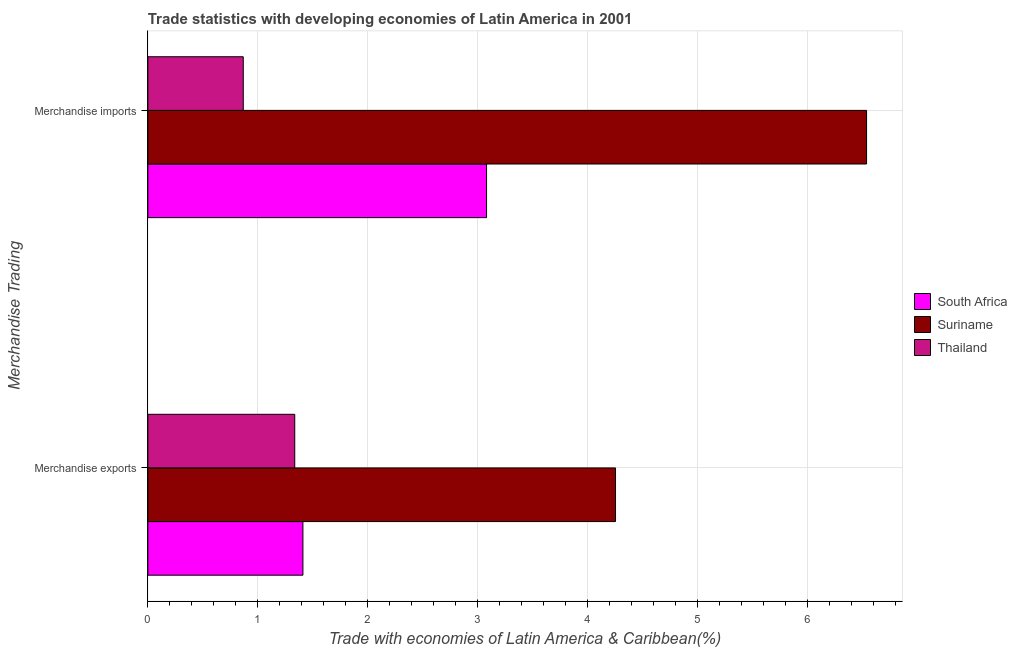How many groups of bars are there?
Make the answer very short. 2. Are the number of bars per tick equal to the number of legend labels?
Provide a succinct answer. Yes. Are the number of bars on each tick of the Y-axis equal?
Make the answer very short. Yes. How many bars are there on the 1st tick from the top?
Provide a short and direct response. 3. How many bars are there on the 1st tick from the bottom?
Offer a very short reply. 3. What is the merchandise exports in Thailand?
Provide a succinct answer. 1.34. Across all countries, what is the maximum merchandise exports?
Offer a terse response. 4.25. Across all countries, what is the minimum merchandise exports?
Ensure brevity in your answer.  1.34. In which country was the merchandise exports maximum?
Your response must be concise. Suriname. In which country was the merchandise exports minimum?
Provide a short and direct response. Thailand. What is the total merchandise imports in the graph?
Provide a short and direct response. 10.48. What is the difference between the merchandise exports in Thailand and that in South Africa?
Your answer should be compact. -0.07. What is the difference between the merchandise exports in Suriname and the merchandise imports in Thailand?
Provide a short and direct response. 3.38. What is the average merchandise exports per country?
Provide a succinct answer. 2.33. What is the difference between the merchandise exports and merchandise imports in South Africa?
Keep it short and to the point. -1.67. In how many countries, is the merchandise exports greater than 2 %?
Give a very brief answer. 1. What is the ratio of the merchandise imports in Suriname to that in South Africa?
Offer a very short reply. 2.12. Is the merchandise imports in Suriname less than that in Thailand?
Offer a very short reply. No. What does the 2nd bar from the top in Merchandise exports represents?
Provide a short and direct response. Suriname. What does the 2nd bar from the bottom in Merchandise imports represents?
Make the answer very short. Suriname. How many countries are there in the graph?
Your response must be concise. 3. Where does the legend appear in the graph?
Provide a short and direct response. Center right. How many legend labels are there?
Give a very brief answer. 3. What is the title of the graph?
Offer a very short reply. Trade statistics with developing economies of Latin America in 2001. What is the label or title of the X-axis?
Give a very brief answer. Trade with economies of Latin America & Caribbean(%). What is the label or title of the Y-axis?
Ensure brevity in your answer.  Merchandise Trading. What is the Trade with economies of Latin America & Caribbean(%) of South Africa in Merchandise exports?
Give a very brief answer. 1.41. What is the Trade with economies of Latin America & Caribbean(%) of Suriname in Merchandise exports?
Provide a short and direct response. 4.25. What is the Trade with economies of Latin America & Caribbean(%) of Thailand in Merchandise exports?
Your answer should be compact. 1.34. What is the Trade with economies of Latin America & Caribbean(%) of South Africa in Merchandise imports?
Make the answer very short. 3.08. What is the Trade with economies of Latin America & Caribbean(%) of Suriname in Merchandise imports?
Offer a very short reply. 6.53. What is the Trade with economies of Latin America & Caribbean(%) of Thailand in Merchandise imports?
Ensure brevity in your answer.  0.87. Across all Merchandise Trading, what is the maximum Trade with economies of Latin America & Caribbean(%) of South Africa?
Offer a very short reply. 3.08. Across all Merchandise Trading, what is the maximum Trade with economies of Latin America & Caribbean(%) in Suriname?
Your answer should be compact. 6.53. Across all Merchandise Trading, what is the maximum Trade with economies of Latin America & Caribbean(%) of Thailand?
Your response must be concise. 1.34. Across all Merchandise Trading, what is the minimum Trade with economies of Latin America & Caribbean(%) of South Africa?
Your response must be concise. 1.41. Across all Merchandise Trading, what is the minimum Trade with economies of Latin America & Caribbean(%) in Suriname?
Your response must be concise. 4.25. Across all Merchandise Trading, what is the minimum Trade with economies of Latin America & Caribbean(%) of Thailand?
Provide a succinct answer. 0.87. What is the total Trade with economies of Latin America & Caribbean(%) of South Africa in the graph?
Provide a short and direct response. 4.49. What is the total Trade with economies of Latin America & Caribbean(%) of Suriname in the graph?
Your response must be concise. 10.78. What is the total Trade with economies of Latin America & Caribbean(%) of Thailand in the graph?
Offer a very short reply. 2.2. What is the difference between the Trade with economies of Latin America & Caribbean(%) of South Africa in Merchandise exports and that in Merchandise imports?
Provide a succinct answer. -1.67. What is the difference between the Trade with economies of Latin America & Caribbean(%) in Suriname in Merchandise exports and that in Merchandise imports?
Ensure brevity in your answer.  -2.28. What is the difference between the Trade with economies of Latin America & Caribbean(%) in Thailand in Merchandise exports and that in Merchandise imports?
Give a very brief answer. 0.47. What is the difference between the Trade with economies of Latin America & Caribbean(%) in South Africa in Merchandise exports and the Trade with economies of Latin America & Caribbean(%) in Suriname in Merchandise imports?
Give a very brief answer. -5.12. What is the difference between the Trade with economies of Latin America & Caribbean(%) in South Africa in Merchandise exports and the Trade with economies of Latin America & Caribbean(%) in Thailand in Merchandise imports?
Provide a succinct answer. 0.54. What is the difference between the Trade with economies of Latin America & Caribbean(%) of Suriname in Merchandise exports and the Trade with economies of Latin America & Caribbean(%) of Thailand in Merchandise imports?
Your answer should be compact. 3.38. What is the average Trade with economies of Latin America & Caribbean(%) in South Africa per Merchandise Trading?
Your answer should be very brief. 2.24. What is the average Trade with economies of Latin America & Caribbean(%) in Suriname per Merchandise Trading?
Offer a very short reply. 5.39. What is the average Trade with economies of Latin America & Caribbean(%) in Thailand per Merchandise Trading?
Give a very brief answer. 1.1. What is the difference between the Trade with economies of Latin America & Caribbean(%) in South Africa and Trade with economies of Latin America & Caribbean(%) in Suriname in Merchandise exports?
Your answer should be compact. -2.84. What is the difference between the Trade with economies of Latin America & Caribbean(%) of South Africa and Trade with economies of Latin America & Caribbean(%) of Thailand in Merchandise exports?
Offer a terse response. 0.07. What is the difference between the Trade with economies of Latin America & Caribbean(%) in Suriname and Trade with economies of Latin America & Caribbean(%) in Thailand in Merchandise exports?
Make the answer very short. 2.92. What is the difference between the Trade with economies of Latin America & Caribbean(%) in South Africa and Trade with economies of Latin America & Caribbean(%) in Suriname in Merchandise imports?
Provide a short and direct response. -3.45. What is the difference between the Trade with economies of Latin America & Caribbean(%) of South Africa and Trade with economies of Latin America & Caribbean(%) of Thailand in Merchandise imports?
Keep it short and to the point. 2.21. What is the difference between the Trade with economies of Latin America & Caribbean(%) in Suriname and Trade with economies of Latin America & Caribbean(%) in Thailand in Merchandise imports?
Provide a succinct answer. 5.67. What is the ratio of the Trade with economies of Latin America & Caribbean(%) of South Africa in Merchandise exports to that in Merchandise imports?
Provide a short and direct response. 0.46. What is the ratio of the Trade with economies of Latin America & Caribbean(%) of Suriname in Merchandise exports to that in Merchandise imports?
Keep it short and to the point. 0.65. What is the ratio of the Trade with economies of Latin America & Caribbean(%) of Thailand in Merchandise exports to that in Merchandise imports?
Provide a short and direct response. 1.54. What is the difference between the highest and the second highest Trade with economies of Latin America & Caribbean(%) in South Africa?
Offer a very short reply. 1.67. What is the difference between the highest and the second highest Trade with economies of Latin America & Caribbean(%) in Suriname?
Make the answer very short. 2.28. What is the difference between the highest and the second highest Trade with economies of Latin America & Caribbean(%) in Thailand?
Offer a very short reply. 0.47. What is the difference between the highest and the lowest Trade with economies of Latin America & Caribbean(%) of South Africa?
Offer a terse response. 1.67. What is the difference between the highest and the lowest Trade with economies of Latin America & Caribbean(%) in Suriname?
Provide a succinct answer. 2.28. What is the difference between the highest and the lowest Trade with economies of Latin America & Caribbean(%) of Thailand?
Offer a very short reply. 0.47. 